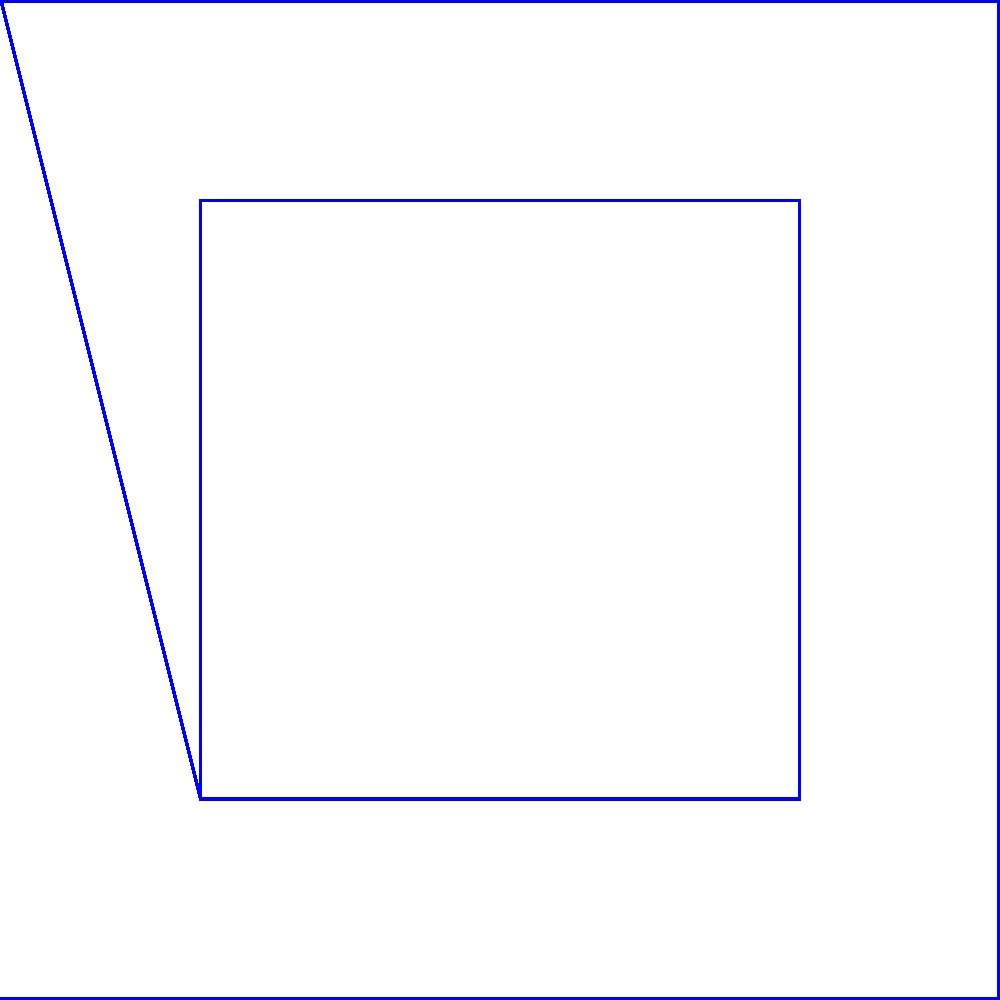In studying the symmetry of indigenous art motifs, a square pattern is reflected across multiple axes. If the original motif (blue) undergoes reflections across the diagonal axes (dashed lines), how many unique orientations of the motif are produced, including the original? To determine the number of unique orientations:

1. Original motif (blue): This is the starting point.

2. Reflection across the diagonal from (0,0) to (1,1):
   - This produces the orange motif.
   - This is a new, unique orientation.

3. Reflection across the diagonal from (0,1) to (1,0):
   - This produces the red and green motifs.
   - These are identical to each other due to the symmetry of the original motif.
   - This represents one new, unique orientation.

4. Count the unique orientations:
   - Original (blue)
   - Diagonal reflection 1 (orange)
   - Diagonal reflection 2 (red/green)

Therefore, there are 3 unique orientations of the motif produced by these reflections, including the original.
Answer: 3 